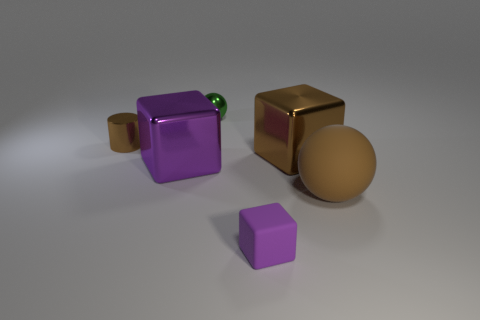There is a large ball that is the same color as the metallic cylinder; what is its material?
Give a very brief answer. Rubber. What is the size of the block that is the same color as the small rubber object?
Offer a terse response. Large. What number of balls are either rubber objects or tiny brown objects?
Provide a succinct answer. 1. The big rubber ball is what color?
Offer a very short reply. Brown. Do the sphere that is in front of the green sphere and the block that is behind the big purple shiny thing have the same size?
Offer a terse response. Yes. Is the number of brown rubber things less than the number of gray rubber cylinders?
Offer a very short reply. No. There is a purple rubber block; what number of shiny objects are to the left of it?
Your response must be concise. 3. What is the small purple block made of?
Provide a succinct answer. Rubber. Does the big sphere have the same color as the shiny cylinder?
Your answer should be very brief. Yes. Are there fewer small brown things that are in front of the small brown shiny thing than large yellow cylinders?
Provide a succinct answer. No. 